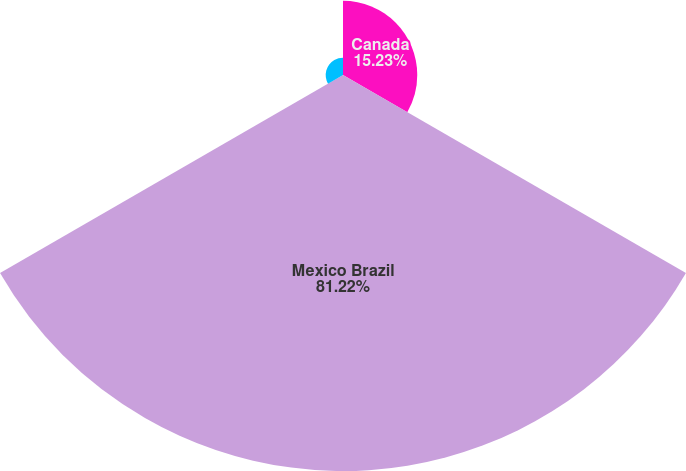Convert chart to OTSL. <chart><loc_0><loc_0><loc_500><loc_500><pie_chart><fcel>Canada<fcel>Mexico Brazil<fcel>Total Company<nl><fcel>15.23%<fcel>81.22%<fcel>3.55%<nl></chart> 